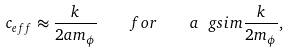<formula> <loc_0><loc_0><loc_500><loc_500>c _ { e f f } \approx \frac { k } { 2 a m _ { \phi } } \quad f o r \quad a \ g s i m \frac { k } { 2 m _ { \phi } } ,</formula> 